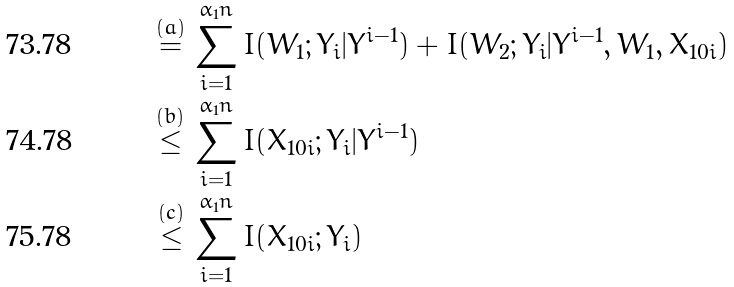Convert formula to latex. <formula><loc_0><loc_0><loc_500><loc_500>\stackrel { ( a ) } { = } & \, \sum _ { i = 1 } ^ { \alpha _ { 1 } n } I ( W _ { 1 } ; Y _ { i } | Y ^ { i - 1 } ) + I ( W _ { 2 } ; Y _ { i } | Y ^ { i - 1 } , W _ { 1 } , X _ { 1 0 i } ) \\ \stackrel { ( b ) } { \leq } & \, \sum _ { i = 1 } ^ { \alpha _ { 1 } n } I ( X _ { 1 0 i } ; Y _ { i } | Y ^ { i - 1 } ) \\ \stackrel { ( c ) } { \leq } & \, \sum _ { i = 1 } ^ { \alpha _ { 1 } n } I ( X _ { 1 0 i } ; Y _ { i } )</formula> 